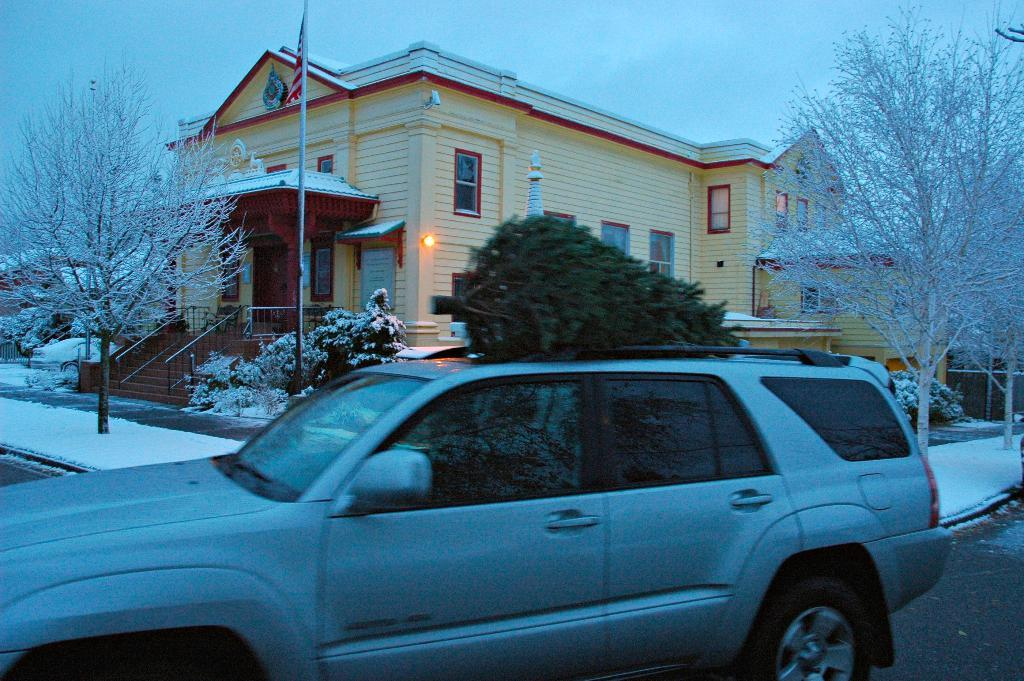What type of structure is visible in the image? There is a house in the image. What mode of transportation can be seen in the image? There is a car in the image. What objects are present in the image that are taller than the house? There are poles in the image. What type of vegetation is visible in the image? There are trees in the image. What weather condition is depicted in the image? There is snow visible in the image. How many beetles can be seen crawling on the car in the image? There are no beetles visible in the image; it only features a house, a car, poles, trees, and snow. What type of step is present in the image? There is no step present in the image. 